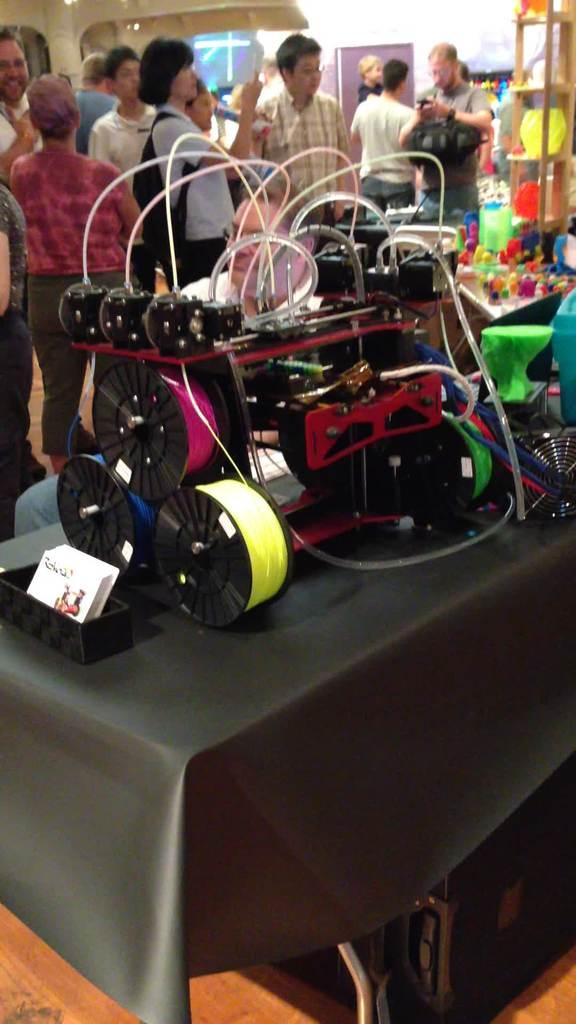What type of furniture is present in the image? There is a table in the image. What is placed on the table? There is an electrical equipment on the table. What can be seen in the background of the image? There is a wall and a photo frame in the background of the image. Are there any people in the image? Yes, there are people present in the image. What historical event is depicted in the photo frame in the image? There is no information about the content of the photo frame in the image, so it cannot be determined if a historical event is depicted. 